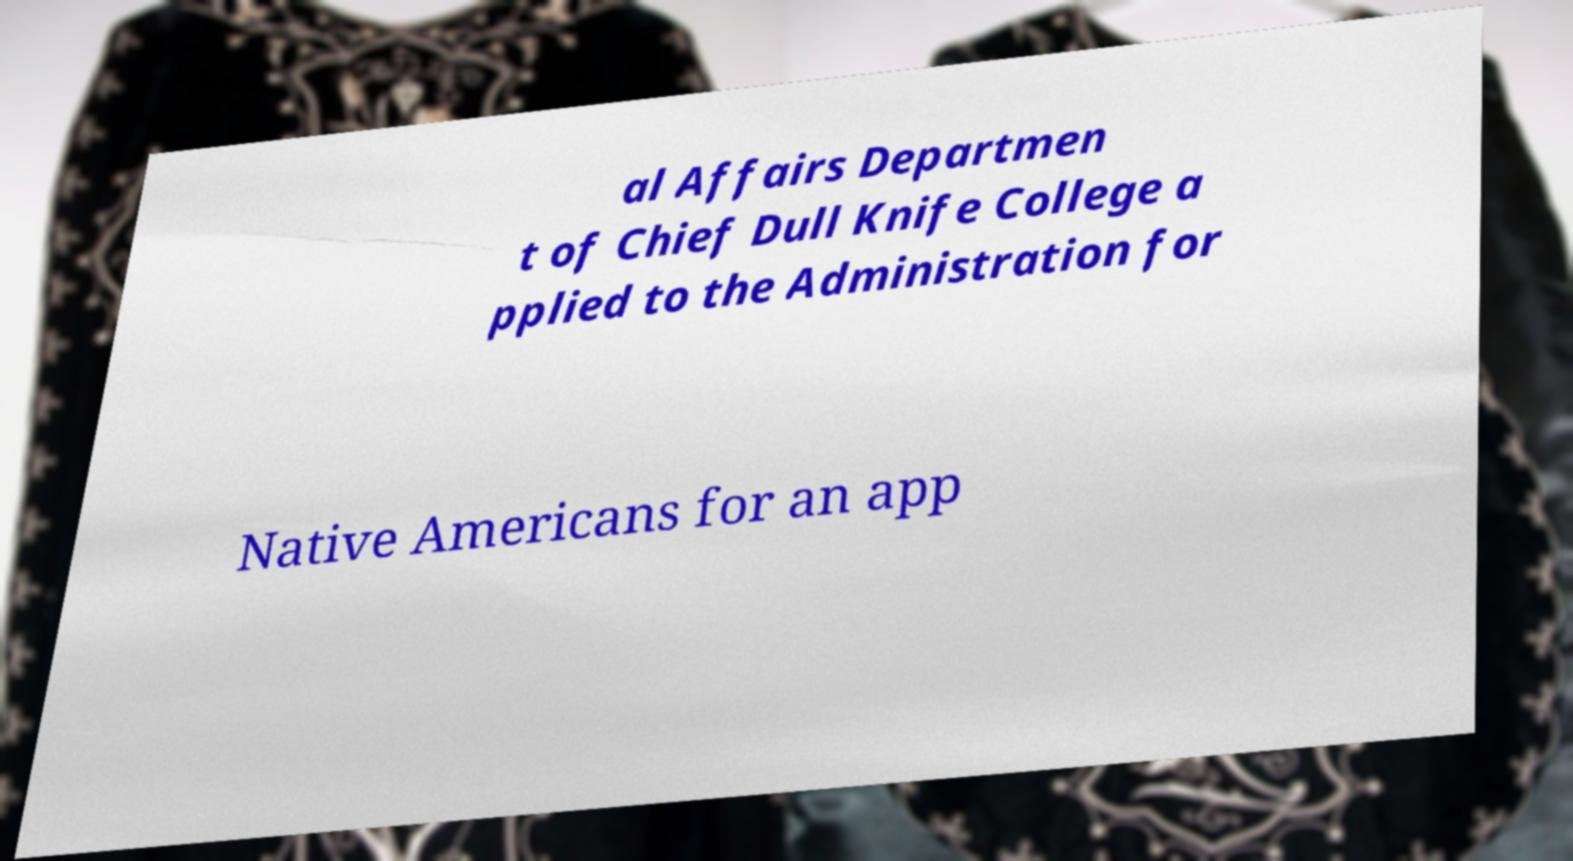There's text embedded in this image that I need extracted. Can you transcribe it verbatim? al Affairs Departmen t of Chief Dull Knife College a pplied to the Administration for Native Americans for an app 